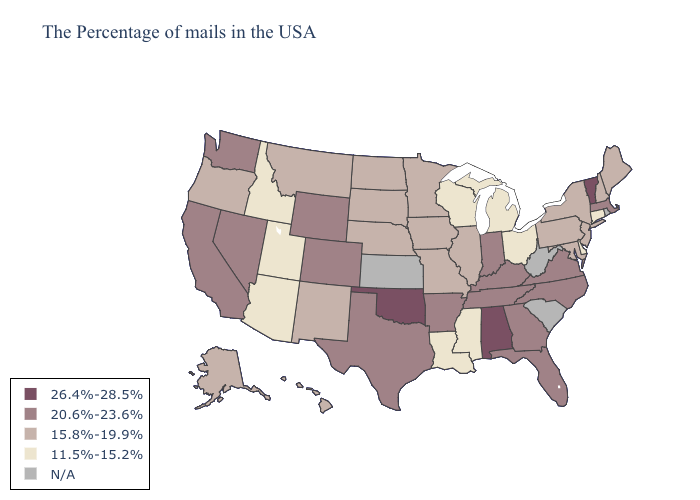Name the states that have a value in the range 20.6%-23.6%?
Write a very short answer. Massachusetts, Virginia, North Carolina, Florida, Georgia, Kentucky, Indiana, Tennessee, Arkansas, Texas, Wyoming, Colorado, Nevada, California, Washington. Name the states that have a value in the range 26.4%-28.5%?
Concise answer only. Vermont, Alabama, Oklahoma. Does Hawaii have the highest value in the West?
Short answer required. No. Which states have the lowest value in the USA?
Write a very short answer. Connecticut, Delaware, Ohio, Michigan, Wisconsin, Mississippi, Louisiana, Utah, Arizona, Idaho. Name the states that have a value in the range 15.8%-19.9%?
Short answer required. Maine, New Hampshire, New York, New Jersey, Maryland, Pennsylvania, Illinois, Missouri, Minnesota, Iowa, Nebraska, South Dakota, North Dakota, New Mexico, Montana, Oregon, Alaska, Hawaii. Does Mississippi have the highest value in the South?
Answer briefly. No. Does the map have missing data?
Quick response, please. Yes. What is the value of Indiana?
Give a very brief answer. 20.6%-23.6%. What is the lowest value in the USA?
Concise answer only. 11.5%-15.2%. Name the states that have a value in the range 26.4%-28.5%?
Give a very brief answer. Vermont, Alabama, Oklahoma. Name the states that have a value in the range 26.4%-28.5%?
Answer briefly. Vermont, Alabama, Oklahoma. Which states have the highest value in the USA?
Be succinct. Vermont, Alabama, Oklahoma. Which states have the lowest value in the South?
Concise answer only. Delaware, Mississippi, Louisiana. Name the states that have a value in the range 26.4%-28.5%?
Answer briefly. Vermont, Alabama, Oklahoma. 